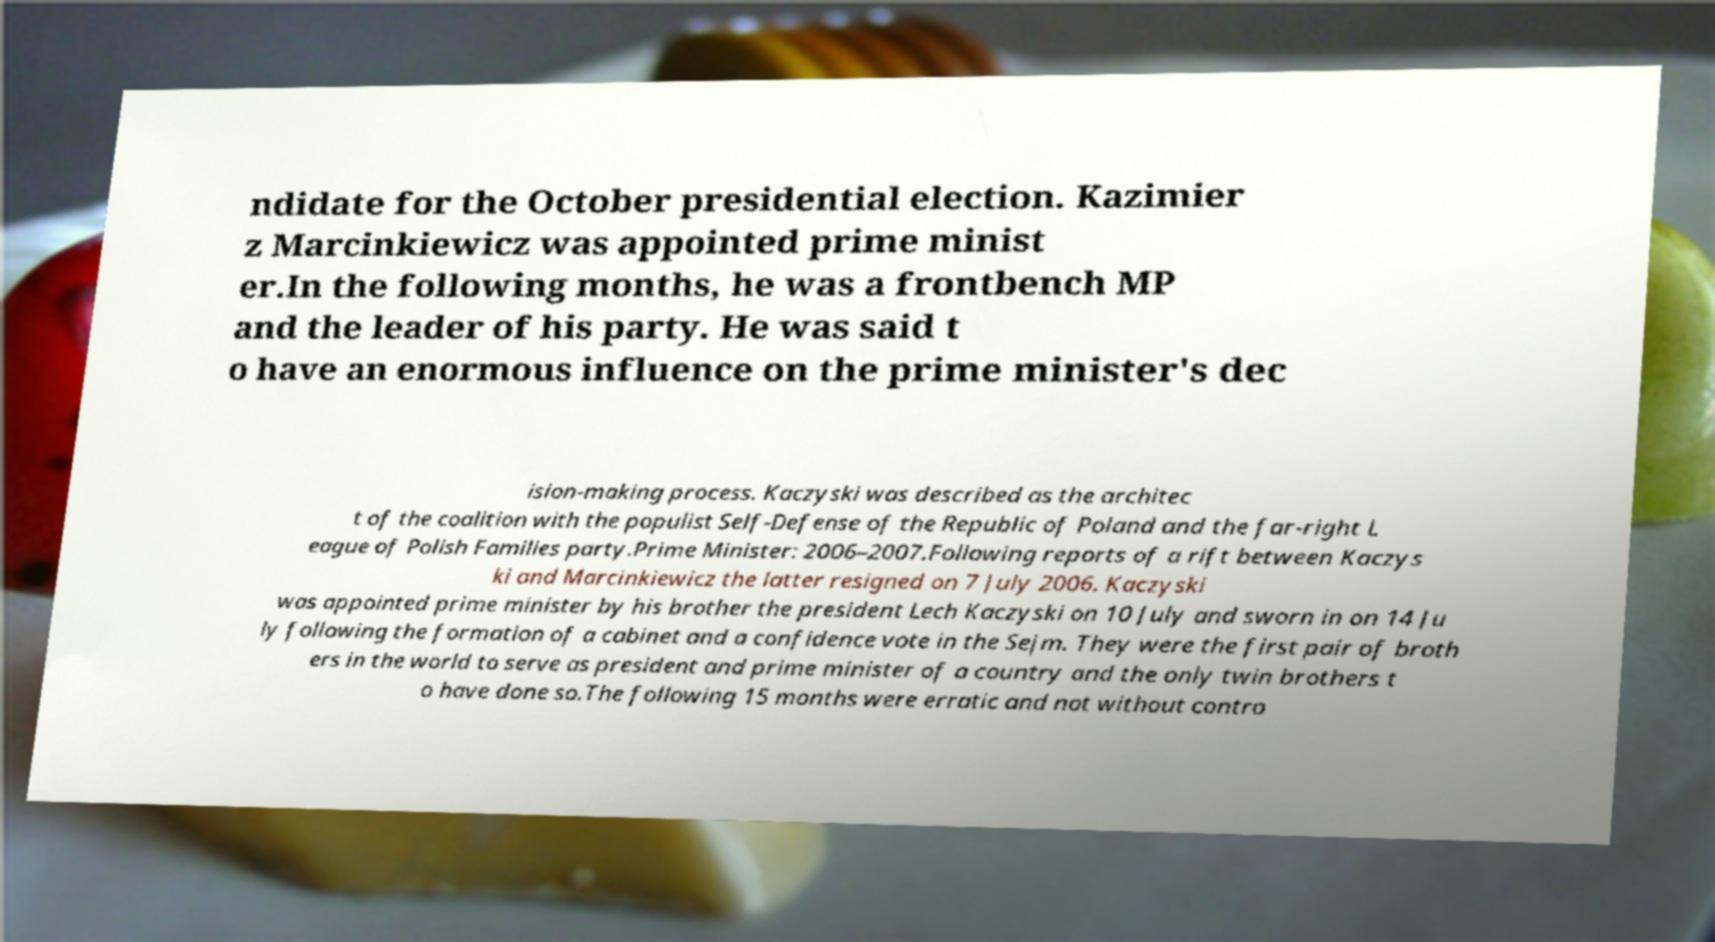Can you read and provide the text displayed in the image?This photo seems to have some interesting text. Can you extract and type it out for me? ndidate for the October presidential election. Kazimier z Marcinkiewicz was appointed prime minist er.In the following months, he was a frontbench MP and the leader of his party. He was said t o have an enormous influence on the prime minister's dec ision-making process. Kaczyski was described as the architec t of the coalition with the populist Self-Defense of the Republic of Poland and the far-right L eague of Polish Families party.Prime Minister: 2006–2007.Following reports of a rift between Kaczys ki and Marcinkiewicz the latter resigned on 7 July 2006. Kaczyski was appointed prime minister by his brother the president Lech Kaczyski on 10 July and sworn in on 14 Ju ly following the formation of a cabinet and a confidence vote in the Sejm. They were the first pair of broth ers in the world to serve as president and prime minister of a country and the only twin brothers t o have done so.The following 15 months were erratic and not without contro 